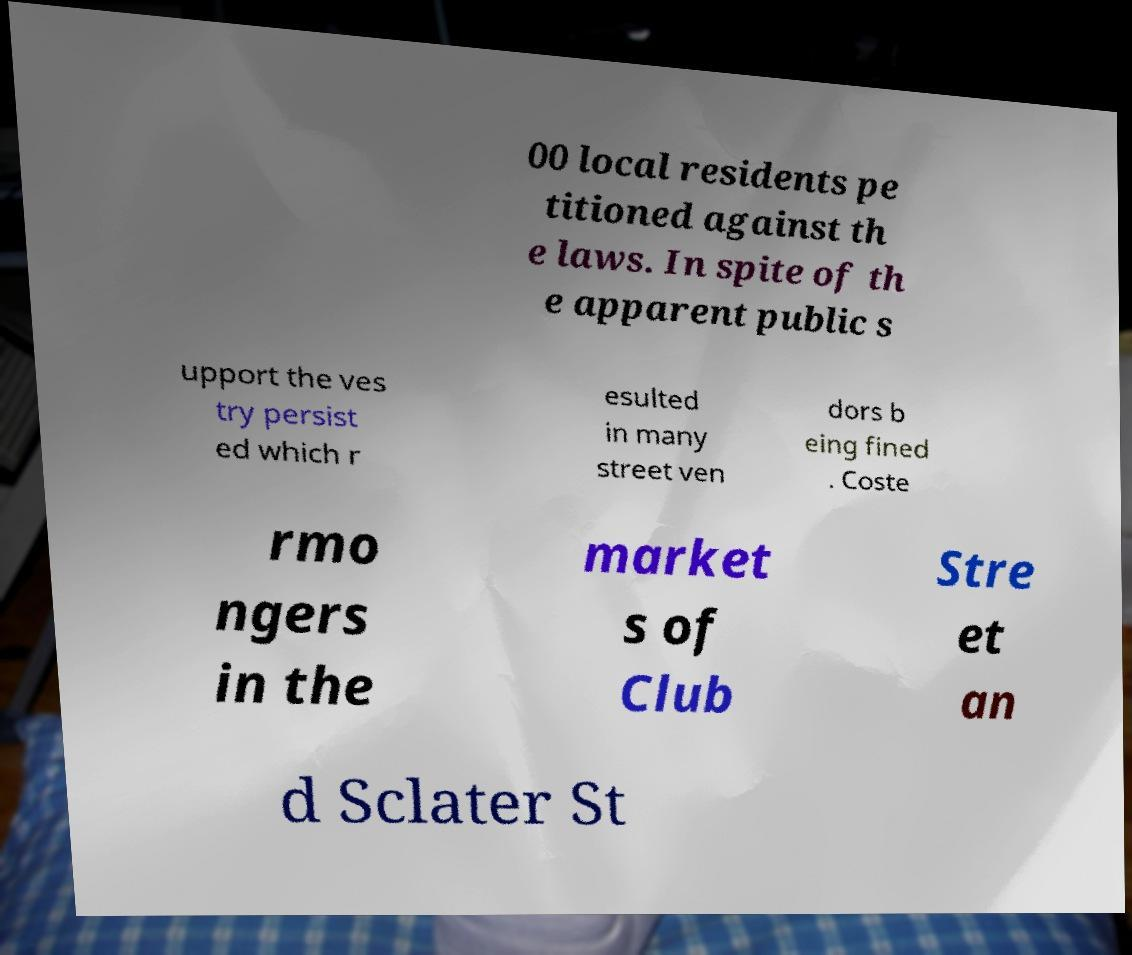Can you read and provide the text displayed in the image?This photo seems to have some interesting text. Can you extract and type it out for me? 00 local residents pe titioned against th e laws. In spite of th e apparent public s upport the ves try persist ed which r esulted in many street ven dors b eing fined . Coste rmo ngers in the market s of Club Stre et an d Sclater St 